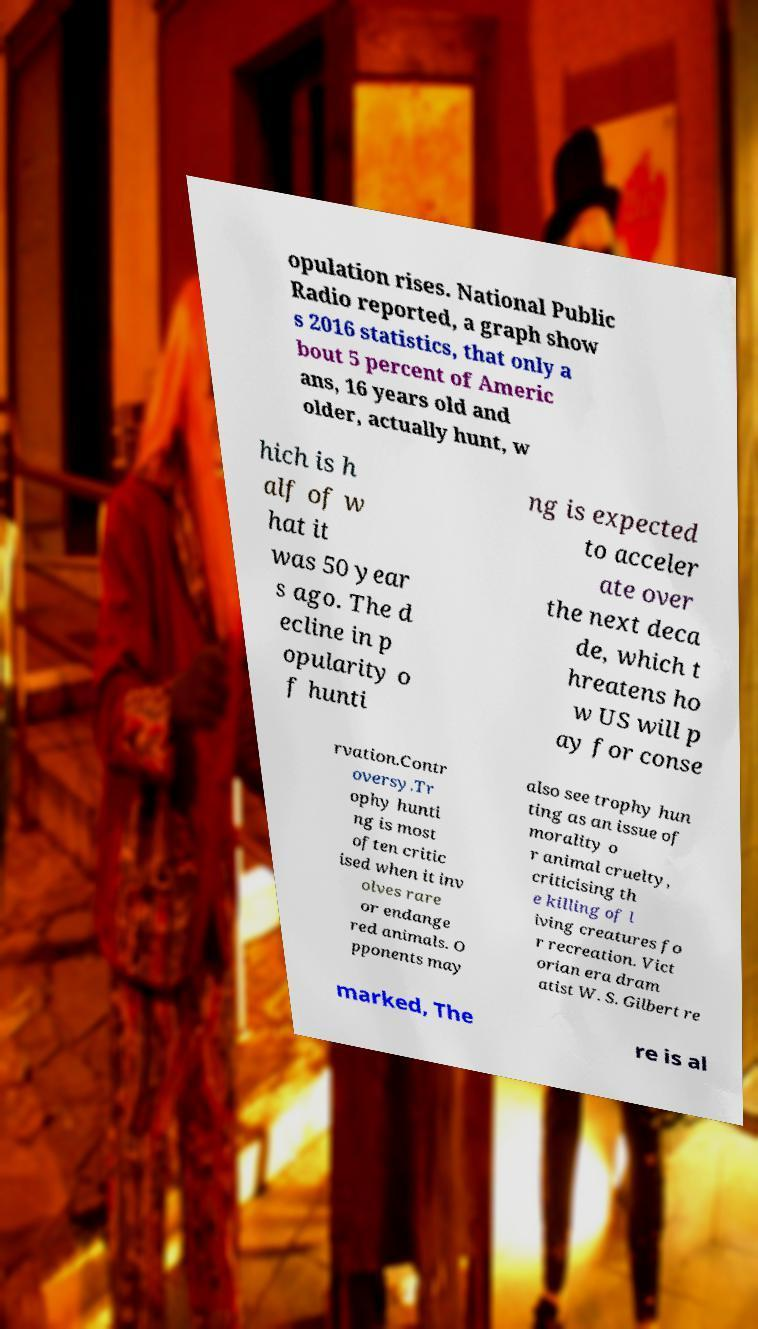There's text embedded in this image that I need extracted. Can you transcribe it verbatim? opulation rises. National Public Radio reported, a graph show s 2016 statistics, that only a bout 5 percent of Americ ans, 16 years old and older, actually hunt, w hich is h alf of w hat it was 50 year s ago. The d ecline in p opularity o f hunti ng is expected to acceler ate over the next deca de, which t hreatens ho w US will p ay for conse rvation.Contr oversy.Tr ophy hunti ng is most often critic ised when it inv olves rare or endange red animals. O pponents may also see trophy hun ting as an issue of morality o r animal cruelty, criticising th e killing of l iving creatures fo r recreation. Vict orian era dram atist W. S. Gilbert re marked, The re is al 